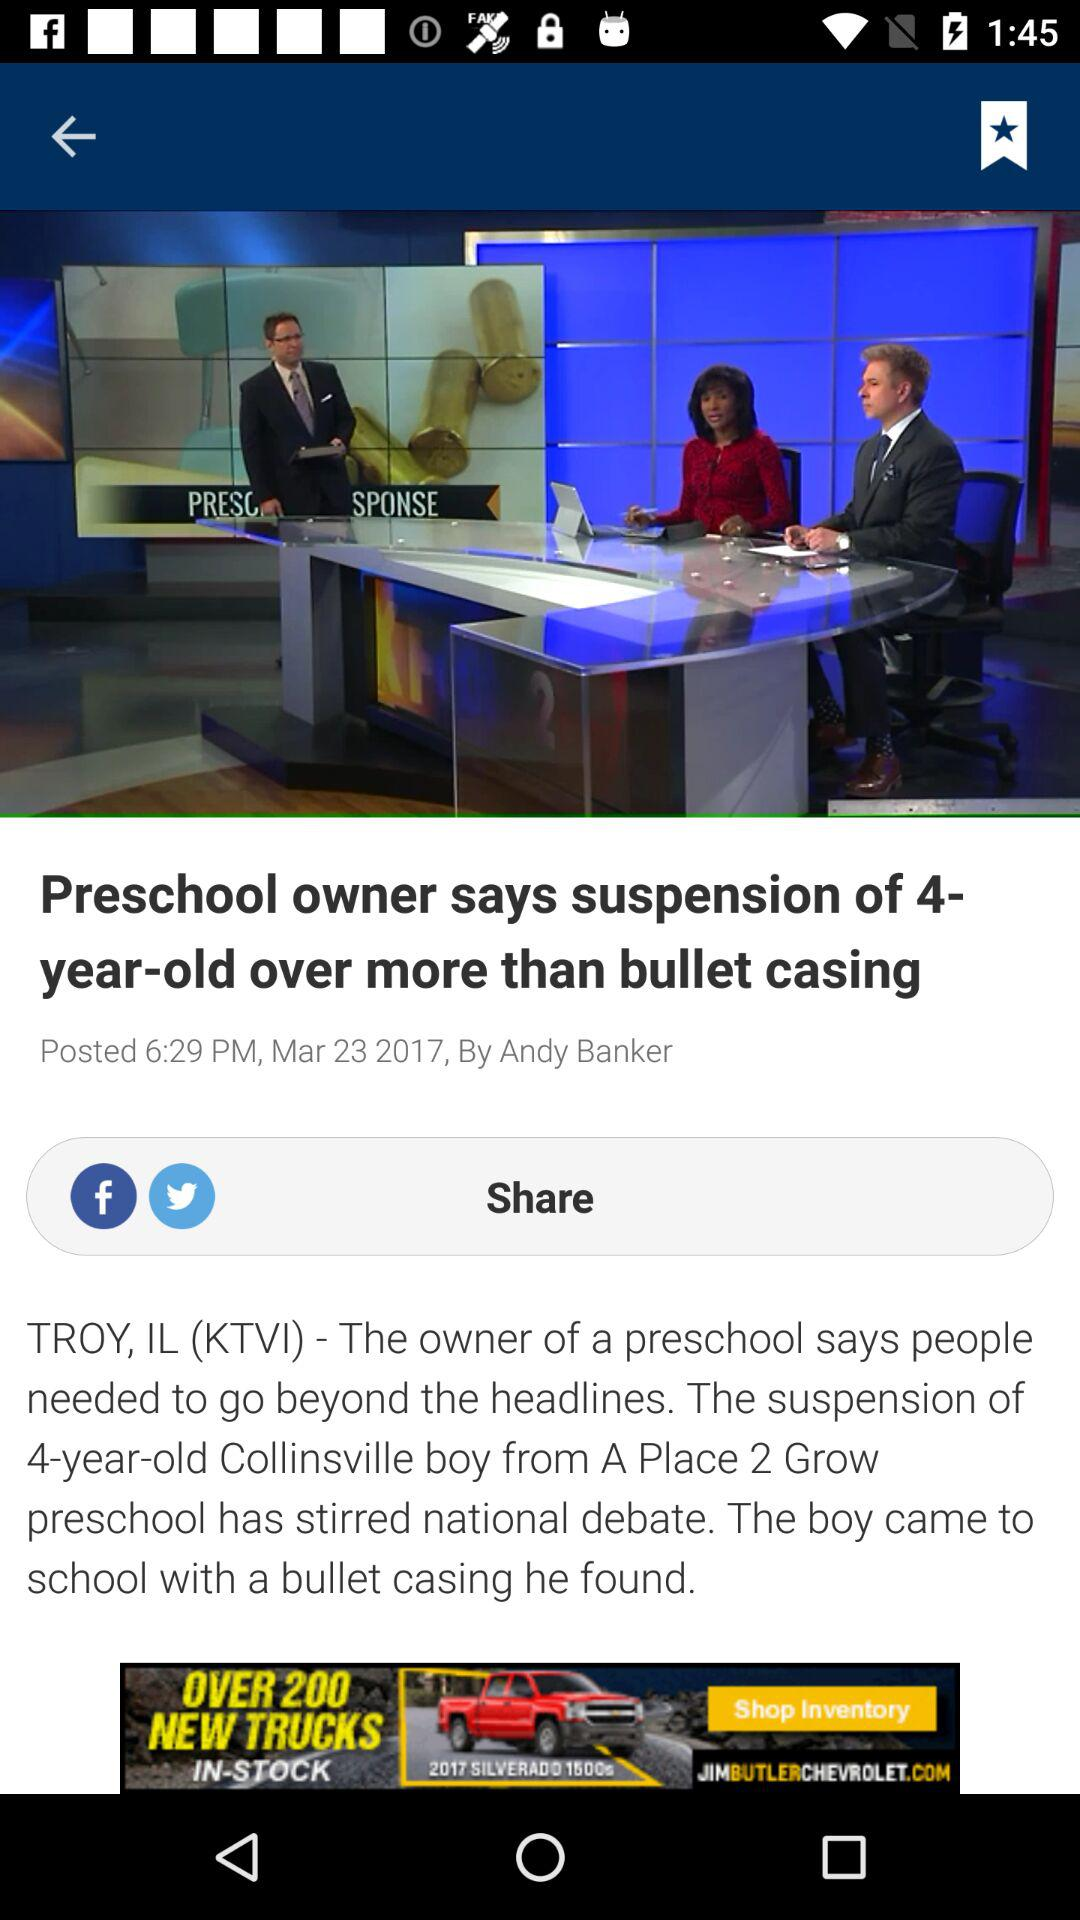Who is the author? The author is Andy Banker. 